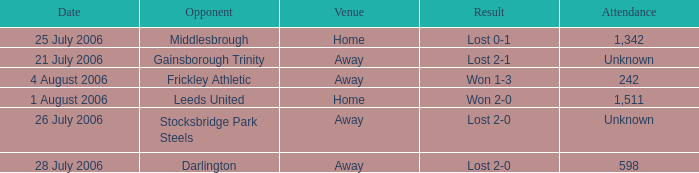What is the result from the Leeds United opponent? Won 2-0. Can you give me this table as a dict? {'header': ['Date', 'Opponent', 'Venue', 'Result', 'Attendance'], 'rows': [['25 July 2006', 'Middlesbrough', 'Home', 'Lost 0-1', '1,342'], ['21 July 2006', 'Gainsborough Trinity', 'Away', 'Lost 2-1', 'Unknown'], ['4 August 2006', 'Frickley Athletic', 'Away', 'Won 1-3', '242'], ['1 August 2006', 'Leeds United', 'Home', 'Won 2-0', '1,511'], ['26 July 2006', 'Stocksbridge Park Steels', 'Away', 'Lost 2-0', 'Unknown'], ['28 July 2006', 'Darlington', 'Away', 'Lost 2-0', '598']]} 